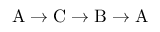<formula> <loc_0><loc_0><loc_500><loc_500>A \to C \to B \to A</formula> 